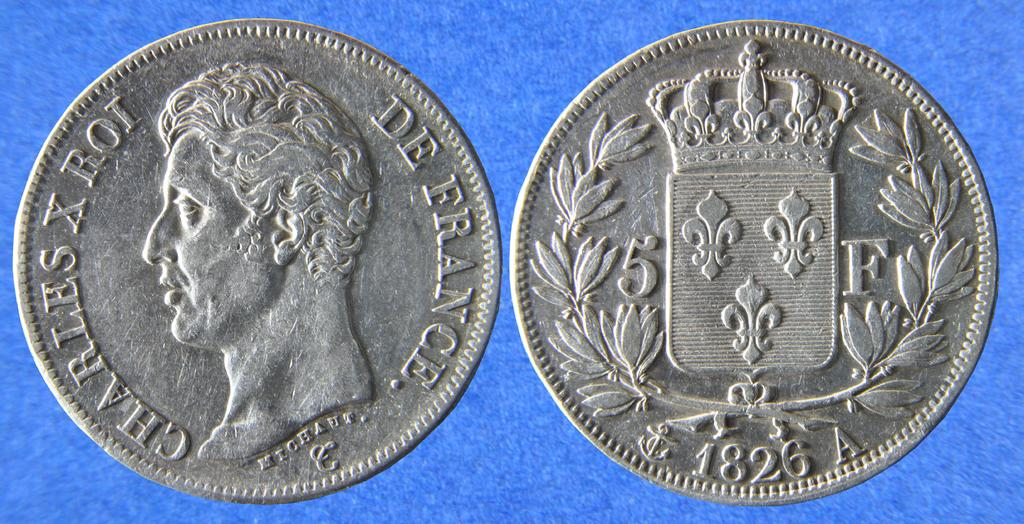<image>
Present a compact description of the photo's key features. Charles X Roi's profile shows on the De France coin. 